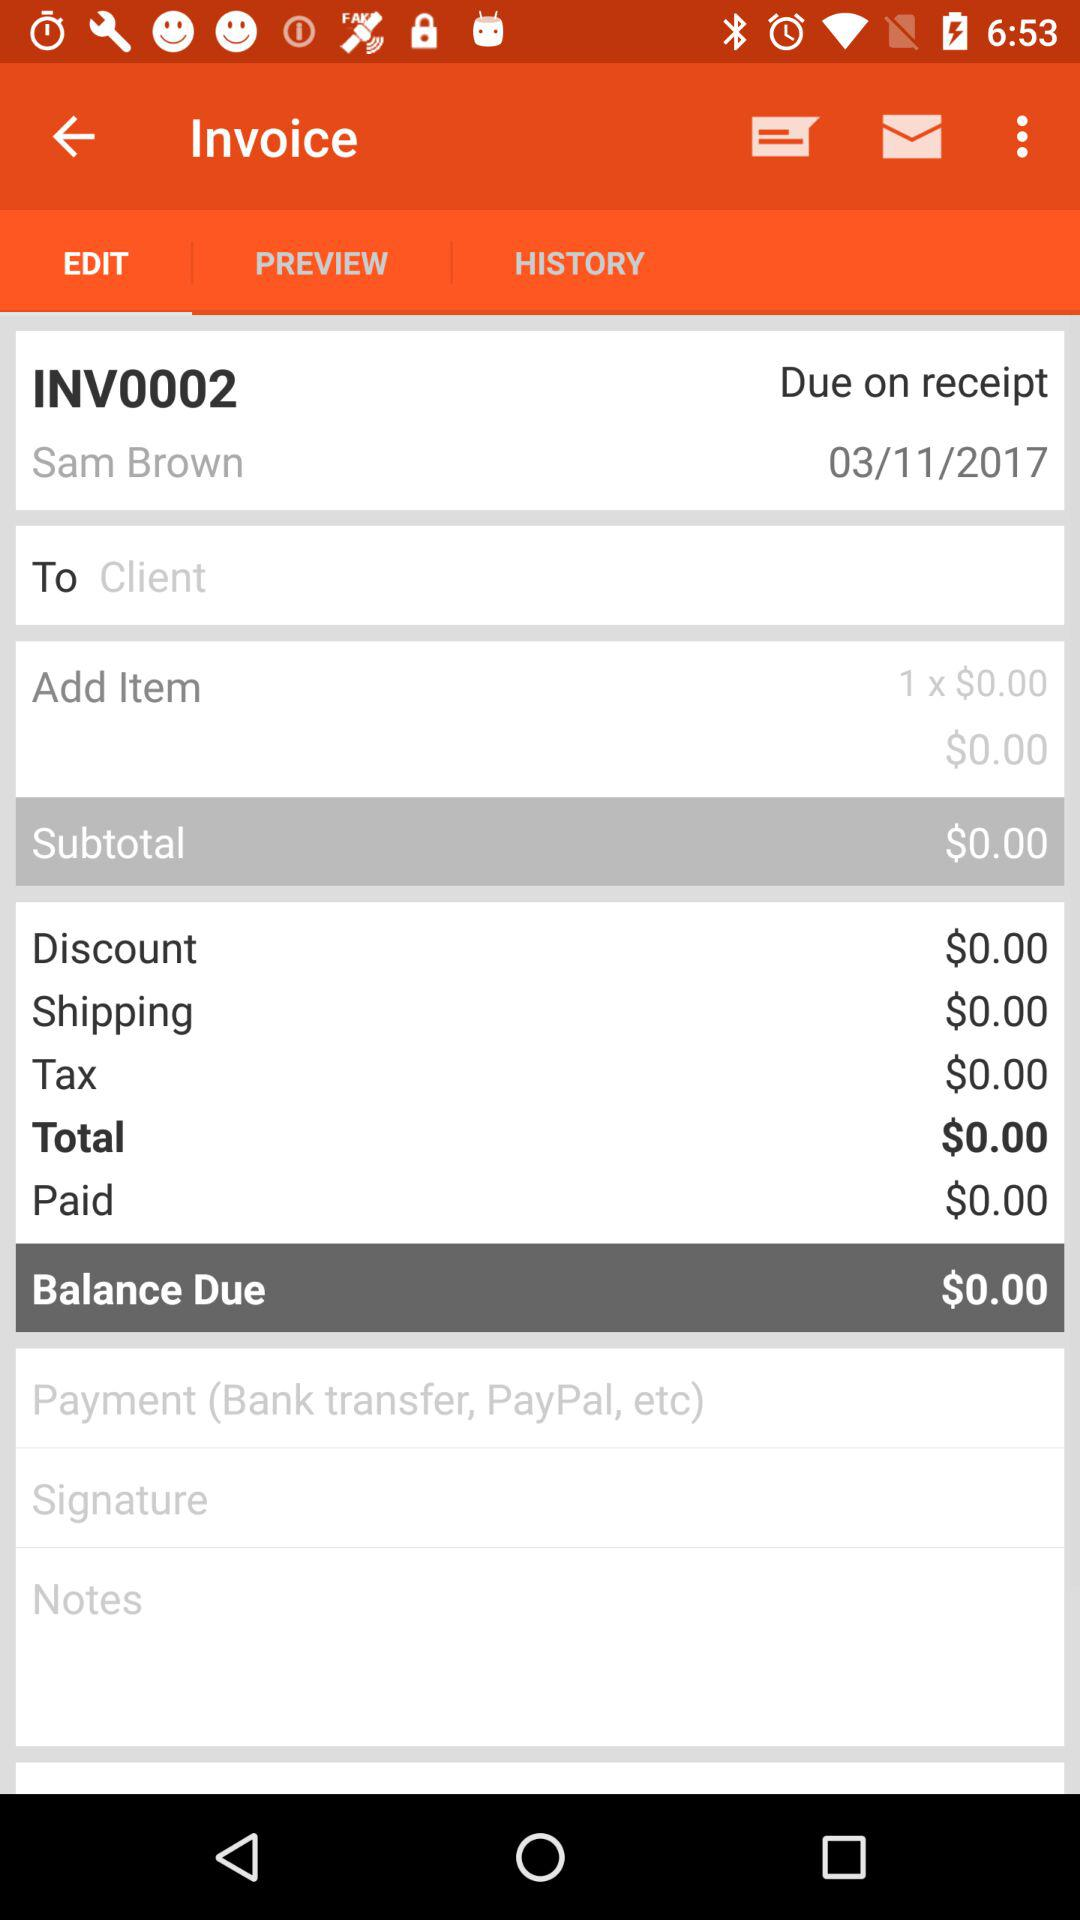What is the due date of the invoice?
Answer the question using a single word or phrase. 03/11/2017 